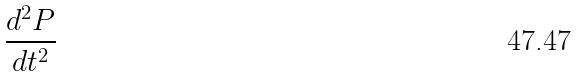Convert formula to latex. <formula><loc_0><loc_0><loc_500><loc_500>\frac { d ^ { 2 } P } { d t ^ { 2 } }</formula> 